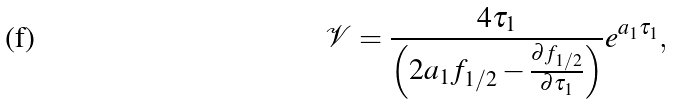Convert formula to latex. <formula><loc_0><loc_0><loc_500><loc_500>\mathcal { V } = \frac { 4 \tau _ { 1 } } { \left ( 2 a _ { 1 } f _ { 1 / 2 } - \frac { \partial f _ { 1 / 2 } } { \partial \tau _ { 1 } } \right ) } e ^ { a _ { 1 } \tau _ { 1 } } ,</formula> 